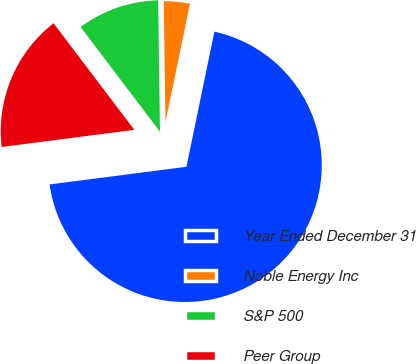<chart> <loc_0><loc_0><loc_500><loc_500><pie_chart><fcel>Year Ended December 31<fcel>Noble Energy Inc<fcel>S&P 500<fcel>Peer Group<nl><fcel>69.71%<fcel>3.47%<fcel>10.1%<fcel>16.72%<nl></chart> 